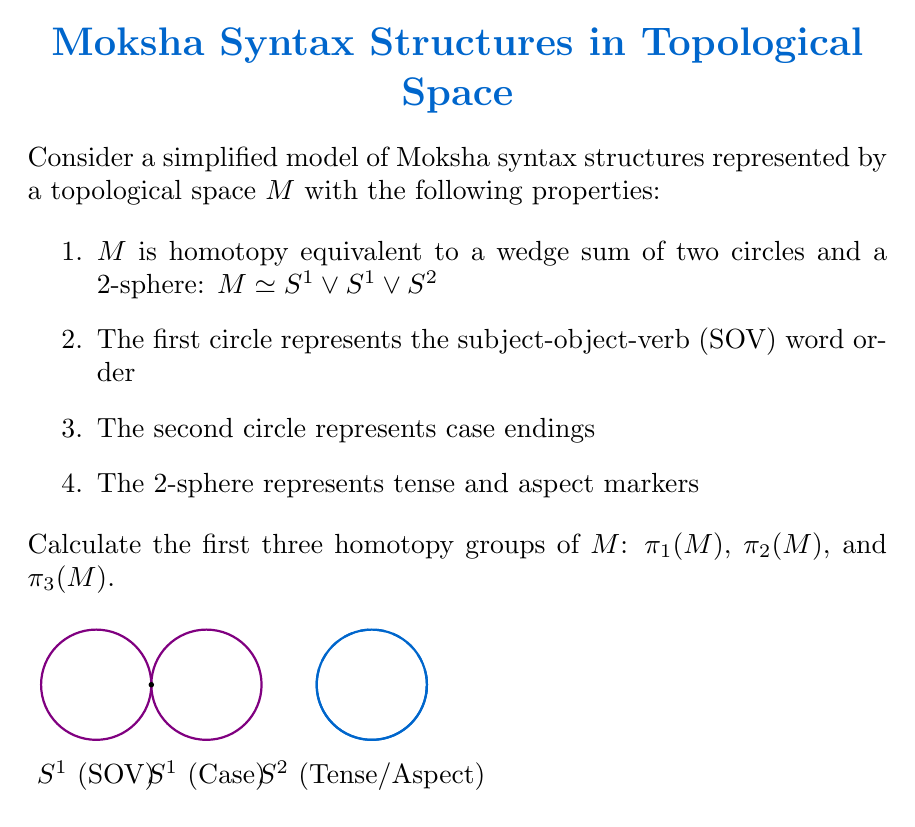Show me your answer to this math problem. Let's approach this step-by-step:

1) First, recall that for a wedge sum $X \vee Y$, we have:
   $\pi_n(X \vee Y) \cong \pi_n(X) \times \pi_n(Y)$ for $n \geq 2$
   $\pi_1(X \vee Y) \cong \pi_1(X) * \pi_1(Y)$ (free product)

2) For $\pi_1(M)$:
   - $\pi_1(S^1) \cong \mathbb{Z}$
   - $\pi_1(S^2) \cong 0$ (trivial group)
   So, $\pi_1(M) \cong \pi_1(S^1 \vee S^1 \vee S^2) \cong \mathbb{Z} * \mathbb{Z} * 0 \cong \mathbb{Z} * \mathbb{Z}$ (free group on two generators)

3) For $\pi_2(M)$:
   - $\pi_2(S^1) \cong 0$
   - $\pi_2(S^2) \cong \mathbb{Z}$
   So, $\pi_2(M) \cong \pi_2(S^1) \times \pi_2(S^1) \times \pi_2(S^2) \cong 0 \times 0 \times \mathbb{Z} \cong \mathbb{Z}$

4) For $\pi_3(M)$:
   - $\pi_3(S^1) \cong 0$
   - $\pi_3(S^2) \cong \mathbb{Z}$ (Hopf fibration)
   So, $\pi_3(M) \cong \pi_3(S^1) \times \pi_3(S^1) \times \pi_3(S^2) \cong 0 \times 0 \times \mathbb{Z} \cong \mathbb{Z}$
Answer: $\pi_1(M) \cong \mathbb{Z} * \mathbb{Z}$, $\pi_2(M) \cong \mathbb{Z}$, $\pi_3(M) \cong \mathbb{Z}$ 